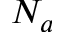<formula> <loc_0><loc_0><loc_500><loc_500>N _ { a }</formula> 